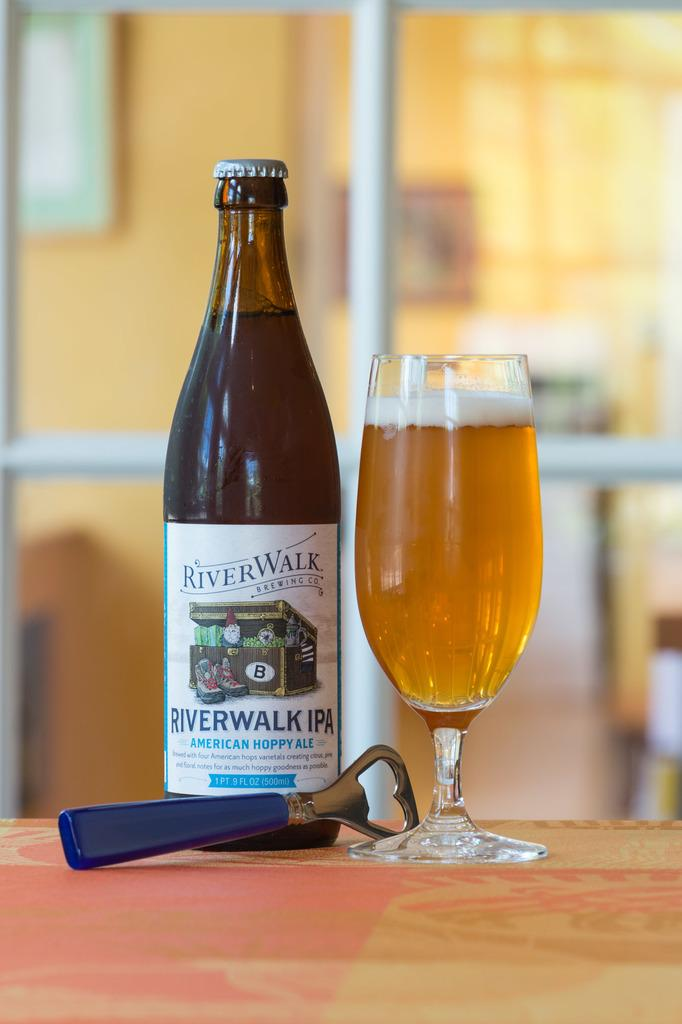<image>
Write a terse but informative summary of the picture. A bottle of Riverwalk IPA sits next to a glass full of the beverage. 